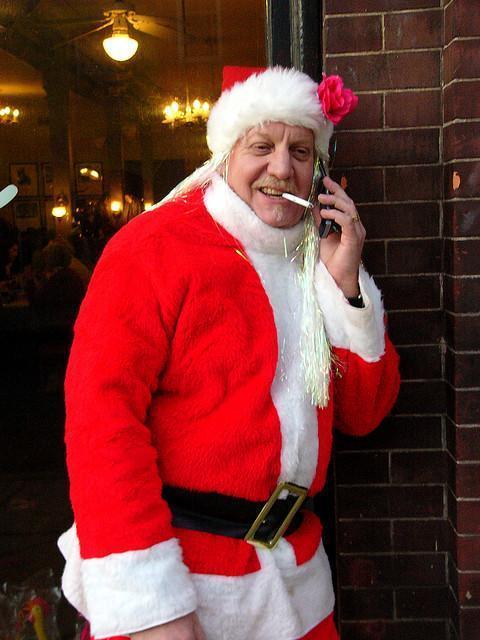How many people are visible?
Give a very brief answer. 2. 